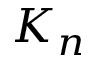<formula> <loc_0><loc_0><loc_500><loc_500>K _ { n }</formula> 